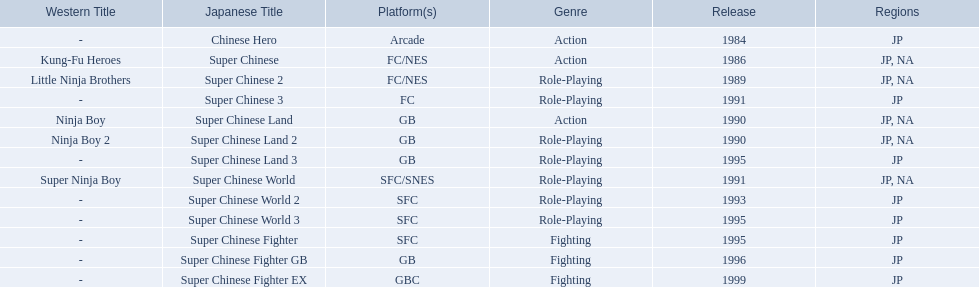What japanese titles were released in the north american (na) region? Super Chinese, Super Chinese 2, Super Chinese Land, Super Chinese Land 2, Super Chinese World. Of those, which one was released most recently? Super Chinese World. 